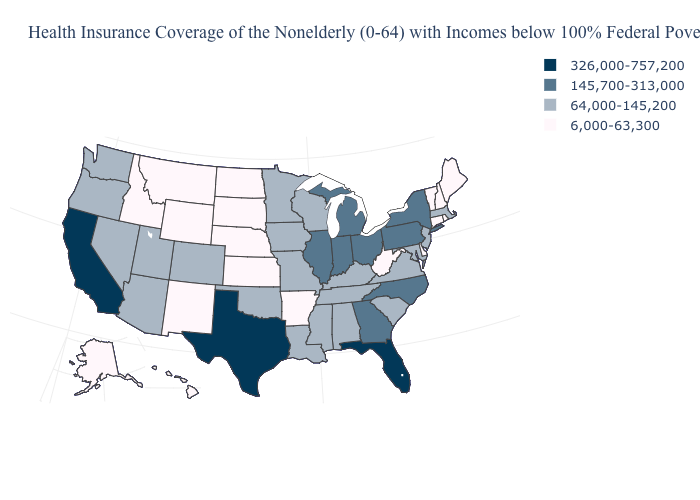What is the lowest value in the West?
Be succinct. 6,000-63,300. Is the legend a continuous bar?
Short answer required. No. How many symbols are there in the legend?
Answer briefly. 4. Does West Virginia have a lower value than Hawaii?
Write a very short answer. No. What is the value of Rhode Island?
Short answer required. 6,000-63,300. Does the map have missing data?
Write a very short answer. No. What is the value of Virginia?
Answer briefly. 64,000-145,200. Does Louisiana have a higher value than Nebraska?
Quick response, please. Yes. Which states have the highest value in the USA?
Be succinct. California, Florida, Texas. How many symbols are there in the legend?
Keep it brief. 4. Name the states that have a value in the range 145,700-313,000?
Write a very short answer. Georgia, Illinois, Indiana, Michigan, New York, North Carolina, Ohio, Pennsylvania. How many symbols are there in the legend?
Be succinct. 4. Does New Hampshire have the highest value in the Northeast?
Concise answer only. No. What is the highest value in the Northeast ?
Short answer required. 145,700-313,000. What is the highest value in states that border Nevada?
Be succinct. 326,000-757,200. 